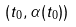<formula> <loc_0><loc_0><loc_500><loc_500>( t _ { 0 } , \alpha ( t _ { 0 } ) )</formula> 